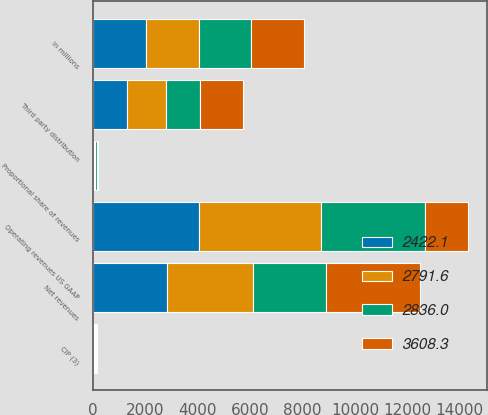Convert chart to OTSL. <chart><loc_0><loc_0><loc_500><loc_500><stacked_bar_chart><ecel><fcel>in millions<fcel>Operating revenues US GAAP<fcel>Proportional share of revenues<fcel>Third party distribution<fcel>CIP (3)<fcel>Net revenues<nl><fcel>3608.3<fcel>2014<fcel>1630.7<fcel>56.7<fcel>1630.7<fcel>35.2<fcel>3608.3<nl><fcel>2791.6<fcel>2013<fcel>4644.6<fcel>51.7<fcel>1489.2<fcel>37.9<fcel>3252<nl><fcel>2422.1<fcel>2012<fcel>4050.4<fcel>37.5<fcel>1308.2<fcel>41<fcel>2836<nl><fcel>2836<fcel>2011<fcel>3982.3<fcel>41.4<fcel>1279.4<fcel>47.3<fcel>2791.6<nl></chart> 